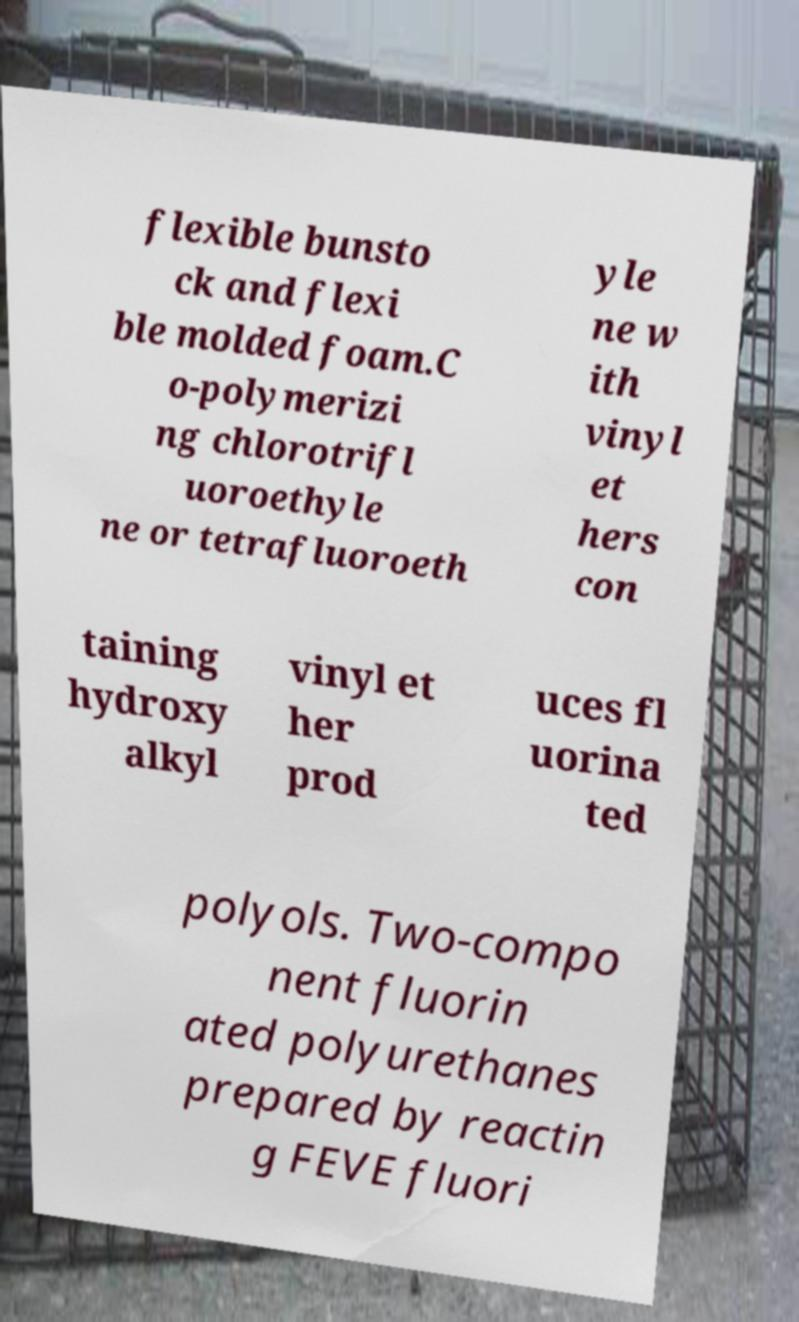What messages or text are displayed in this image? I need them in a readable, typed format. flexible bunsto ck and flexi ble molded foam.C o-polymerizi ng chlorotrifl uoroethyle ne or tetrafluoroeth yle ne w ith vinyl et hers con taining hydroxy alkyl vinyl et her prod uces fl uorina ted polyols. Two-compo nent fluorin ated polyurethanes prepared by reactin g FEVE fluori 